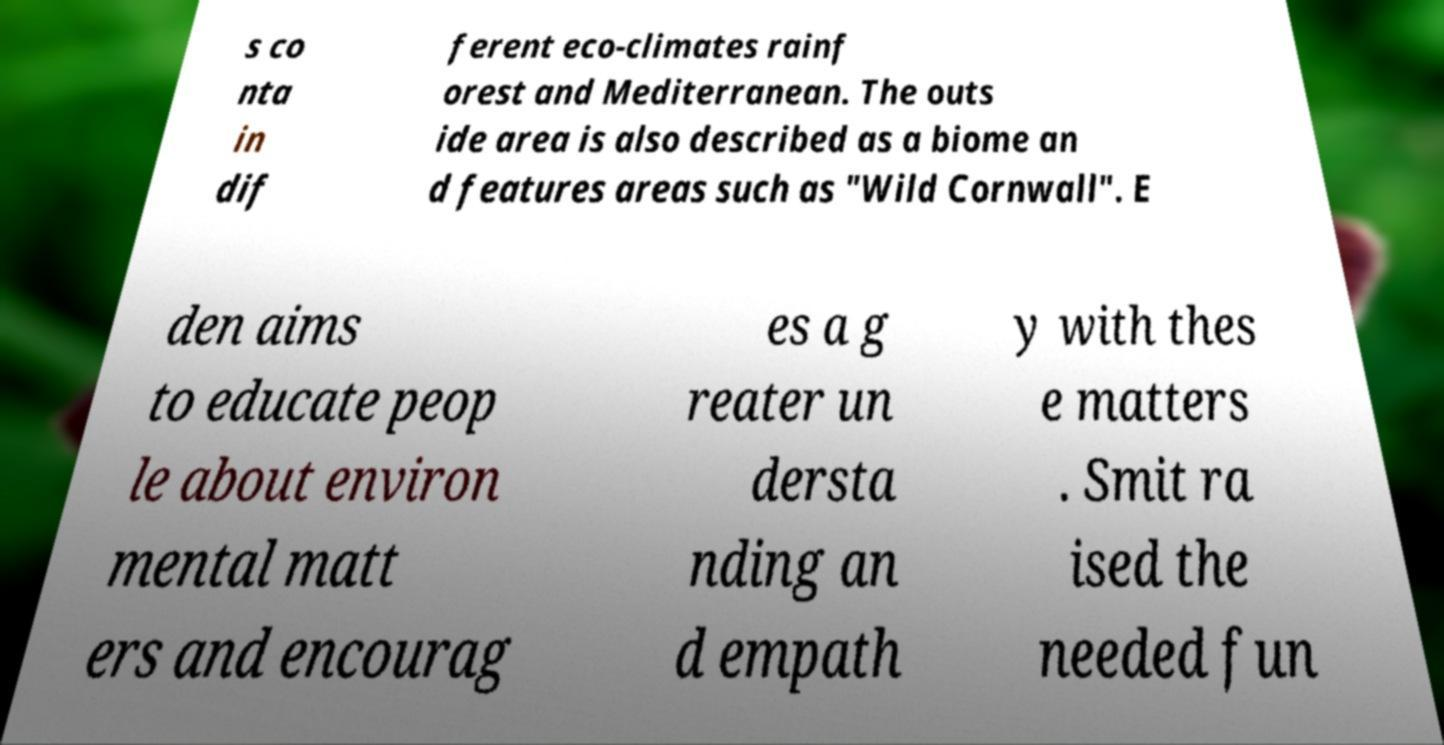For documentation purposes, I need the text within this image transcribed. Could you provide that? s co nta in dif ferent eco-climates rainf orest and Mediterranean. The outs ide area is also described as a biome an d features areas such as "Wild Cornwall". E den aims to educate peop le about environ mental matt ers and encourag es a g reater un dersta nding an d empath y with thes e matters . Smit ra ised the needed fun 